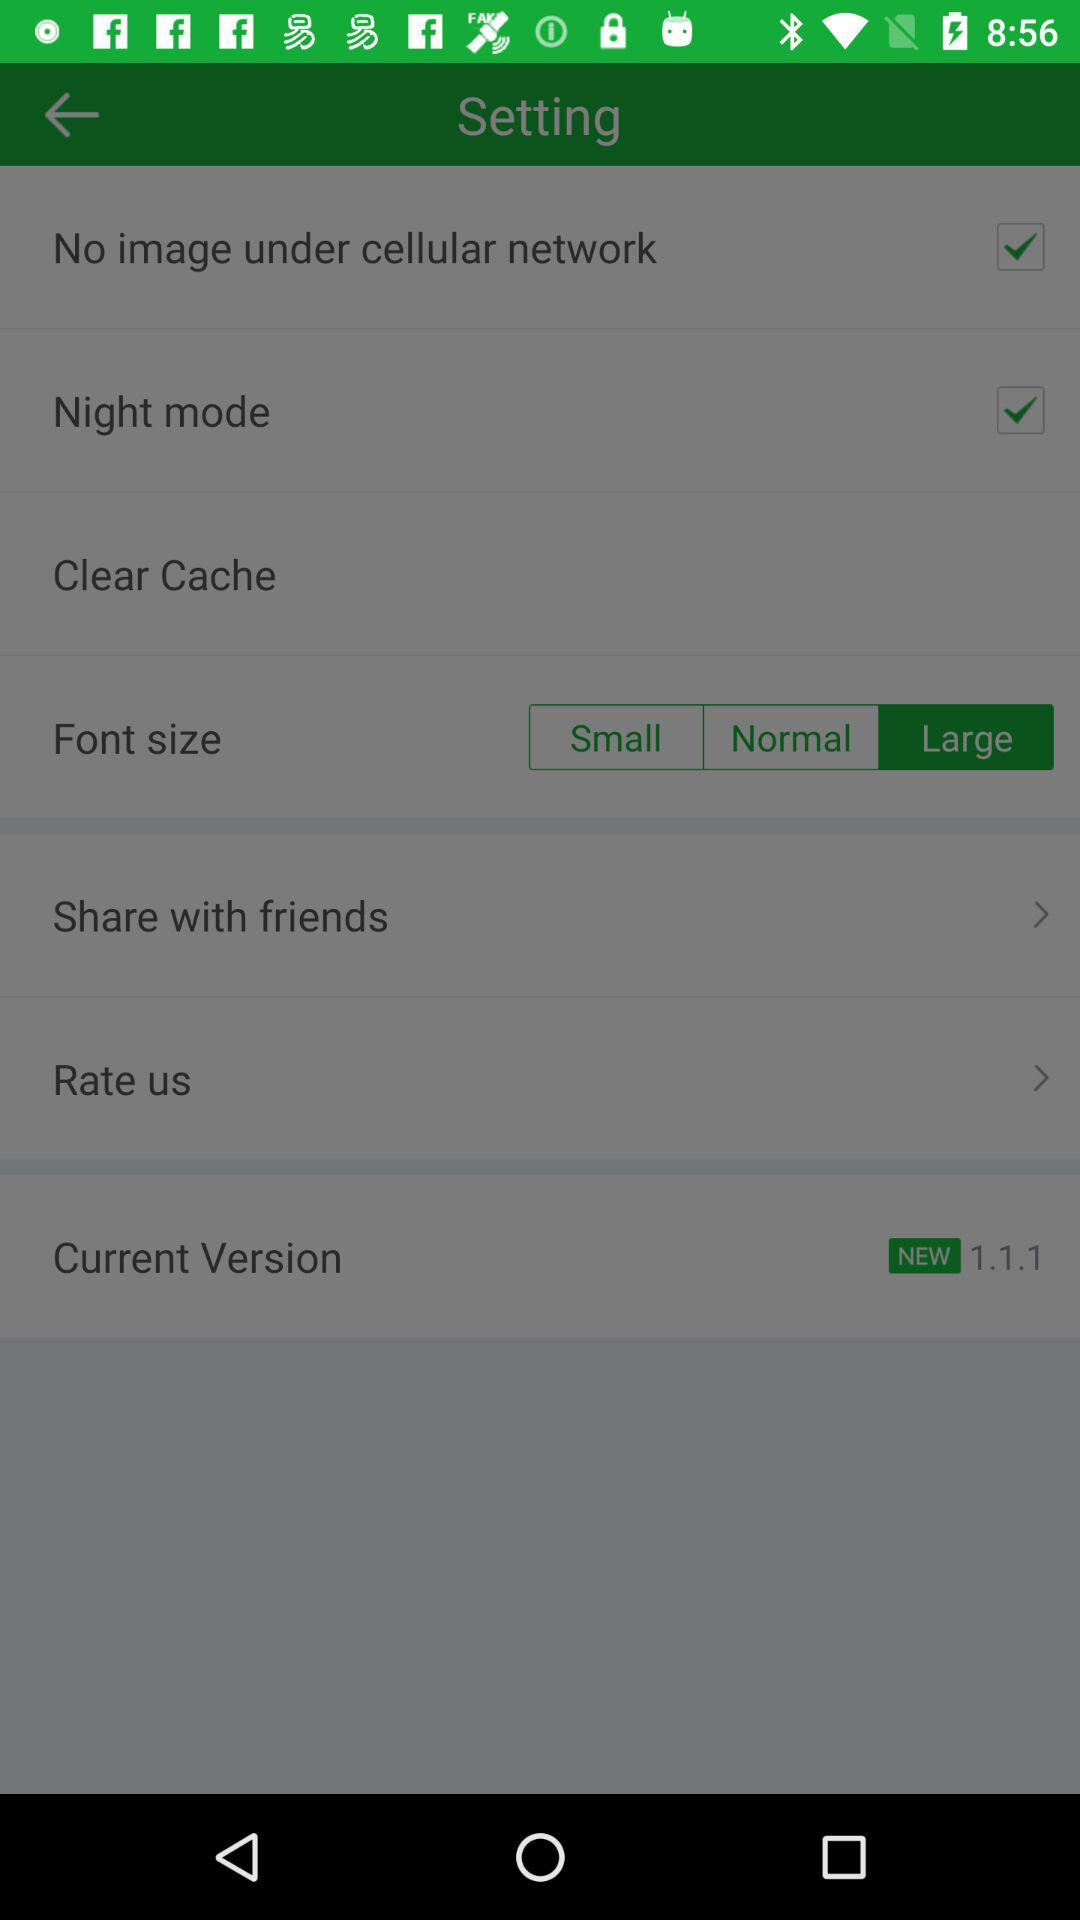What's the selected font size? The selected font size is "Large". 